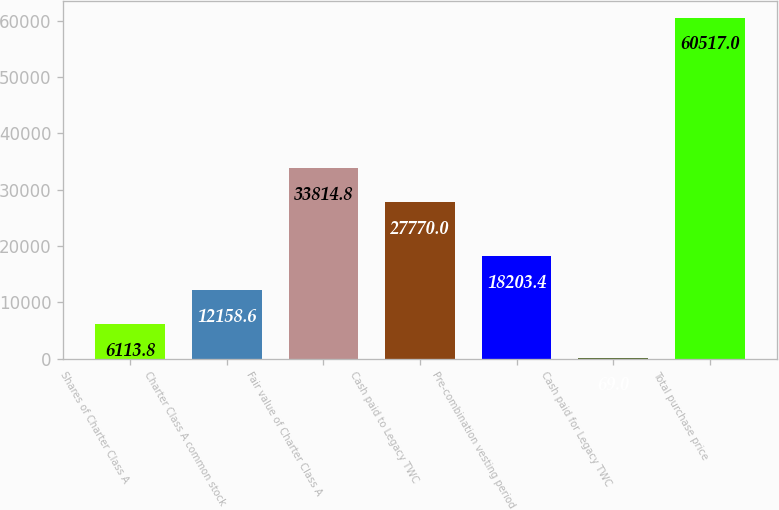Convert chart. <chart><loc_0><loc_0><loc_500><loc_500><bar_chart><fcel>Shares of Charter Class A<fcel>Charter Class A common stock<fcel>Fair value of Charter Class A<fcel>Cash paid to Legacy TWC<fcel>Pre-combination vesting period<fcel>Cash paid for Legacy TWC<fcel>Total purchase price<nl><fcel>6113.8<fcel>12158.6<fcel>33814.8<fcel>27770<fcel>18203.4<fcel>69<fcel>60517<nl></chart> 